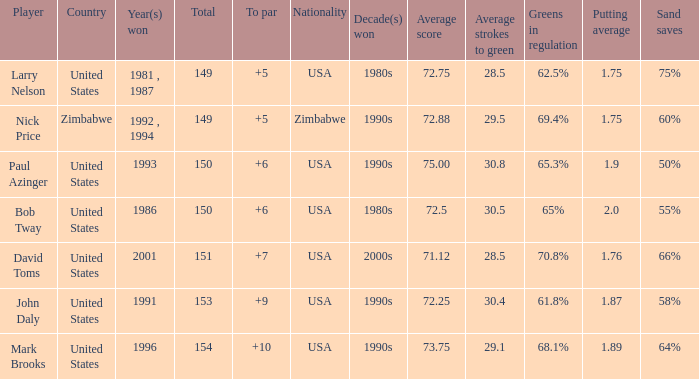What is the total for 1986 with a to par higher than 6? 0.0. 